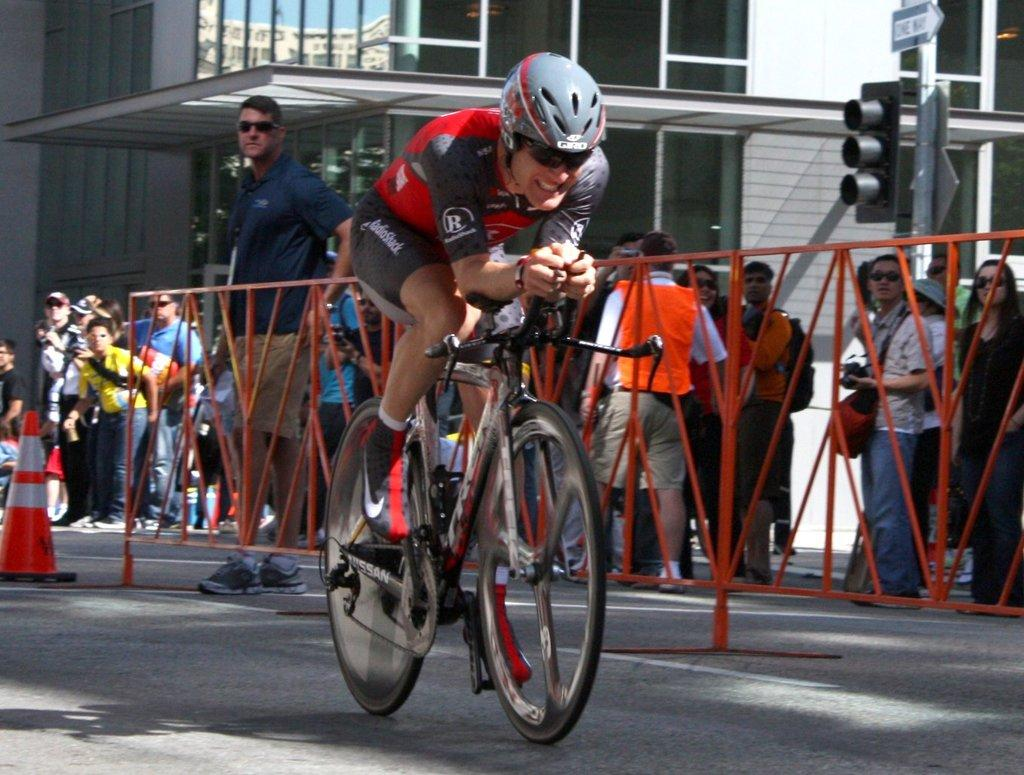Who is the main subject in the image? There is a man in the image. What is the man doing in the image? The man is sitting on a bicycle. Are there any other people in the image? Yes, there are people standing nearby. What are the other people doing in the image? The people are watching the man on the bicycle. What type of seed is the man planting in the image? There is no seed or planting activity present in the image; the man is sitting on a bicycle. 